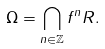Convert formula to latex. <formula><loc_0><loc_0><loc_500><loc_500>\Omega = \bigcap _ { n \in \mathbb { Z } } f ^ { n } R .</formula> 